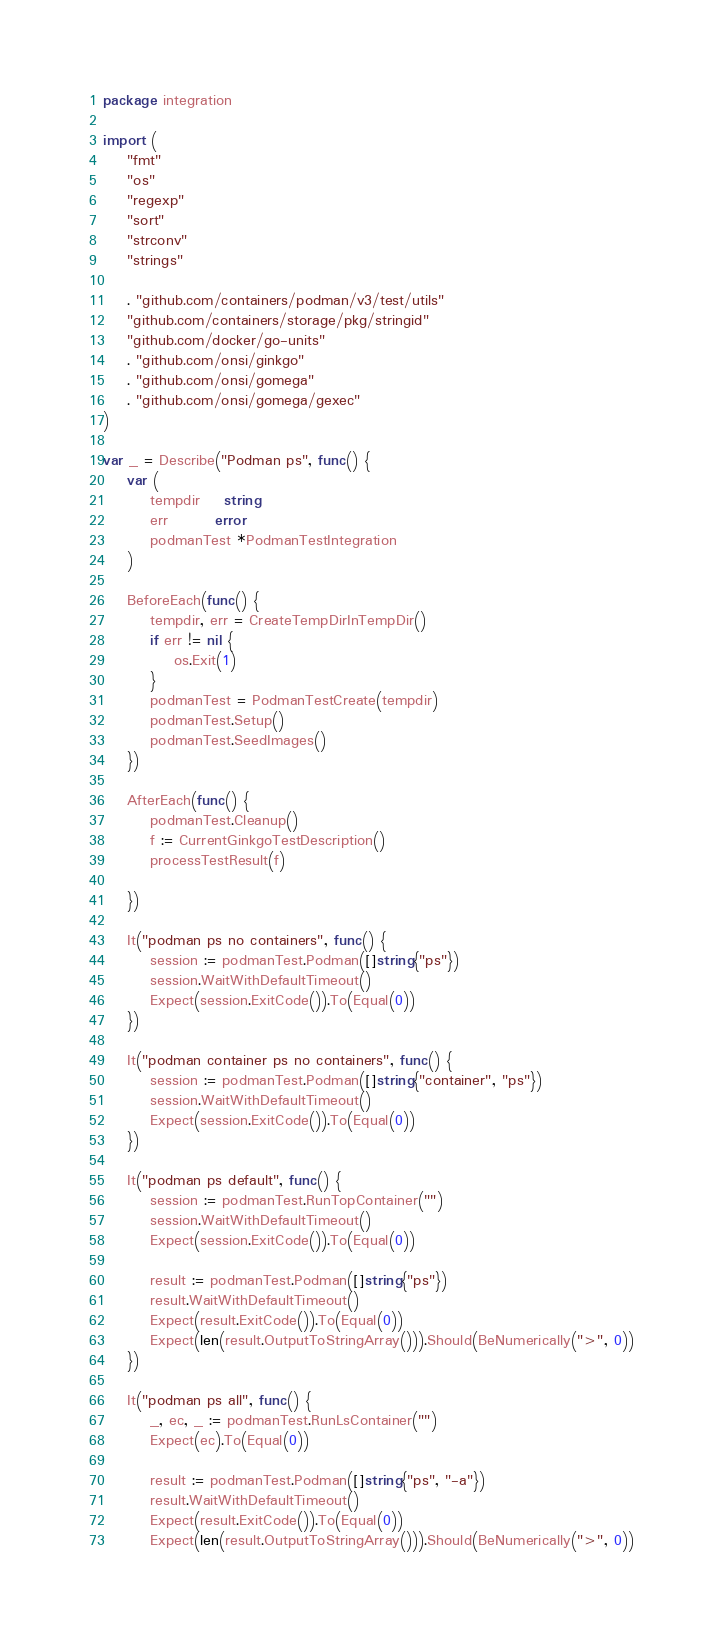Convert code to text. <code><loc_0><loc_0><loc_500><loc_500><_Go_>package integration

import (
	"fmt"
	"os"
	"regexp"
	"sort"
	"strconv"
	"strings"

	. "github.com/containers/podman/v3/test/utils"
	"github.com/containers/storage/pkg/stringid"
	"github.com/docker/go-units"
	. "github.com/onsi/ginkgo"
	. "github.com/onsi/gomega"
	. "github.com/onsi/gomega/gexec"
)

var _ = Describe("Podman ps", func() {
	var (
		tempdir    string
		err        error
		podmanTest *PodmanTestIntegration
	)

	BeforeEach(func() {
		tempdir, err = CreateTempDirInTempDir()
		if err != nil {
			os.Exit(1)
		}
		podmanTest = PodmanTestCreate(tempdir)
		podmanTest.Setup()
		podmanTest.SeedImages()
	})

	AfterEach(func() {
		podmanTest.Cleanup()
		f := CurrentGinkgoTestDescription()
		processTestResult(f)

	})

	It("podman ps no containers", func() {
		session := podmanTest.Podman([]string{"ps"})
		session.WaitWithDefaultTimeout()
		Expect(session.ExitCode()).To(Equal(0))
	})

	It("podman container ps no containers", func() {
		session := podmanTest.Podman([]string{"container", "ps"})
		session.WaitWithDefaultTimeout()
		Expect(session.ExitCode()).To(Equal(0))
	})

	It("podman ps default", func() {
		session := podmanTest.RunTopContainer("")
		session.WaitWithDefaultTimeout()
		Expect(session.ExitCode()).To(Equal(0))

		result := podmanTest.Podman([]string{"ps"})
		result.WaitWithDefaultTimeout()
		Expect(result.ExitCode()).To(Equal(0))
		Expect(len(result.OutputToStringArray())).Should(BeNumerically(">", 0))
	})

	It("podman ps all", func() {
		_, ec, _ := podmanTest.RunLsContainer("")
		Expect(ec).To(Equal(0))

		result := podmanTest.Podman([]string{"ps", "-a"})
		result.WaitWithDefaultTimeout()
		Expect(result.ExitCode()).To(Equal(0))
		Expect(len(result.OutputToStringArray())).Should(BeNumerically(">", 0))</code> 